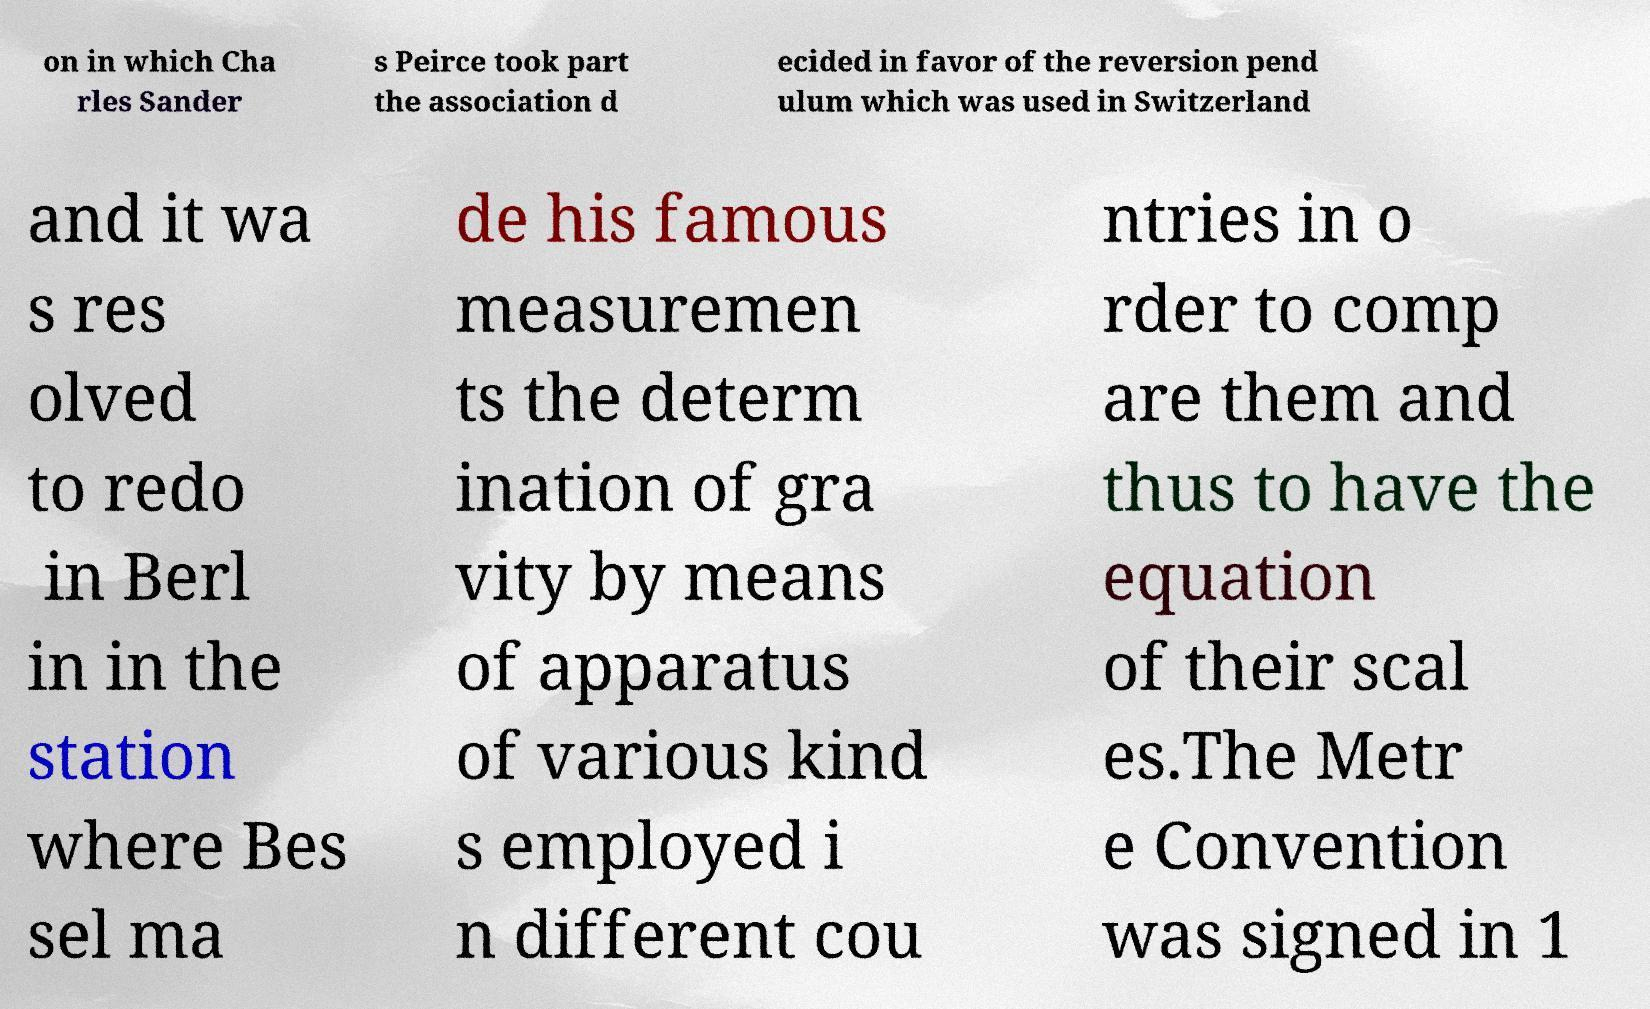Could you assist in decoding the text presented in this image and type it out clearly? on in which Cha rles Sander s Peirce took part the association d ecided in favor of the reversion pend ulum which was used in Switzerland and it wa s res olved to redo in Berl in in the station where Bes sel ma de his famous measuremen ts the determ ination of gra vity by means of apparatus of various kind s employed i n different cou ntries in o rder to comp are them and thus to have the equation of their scal es.The Metr e Convention was signed in 1 